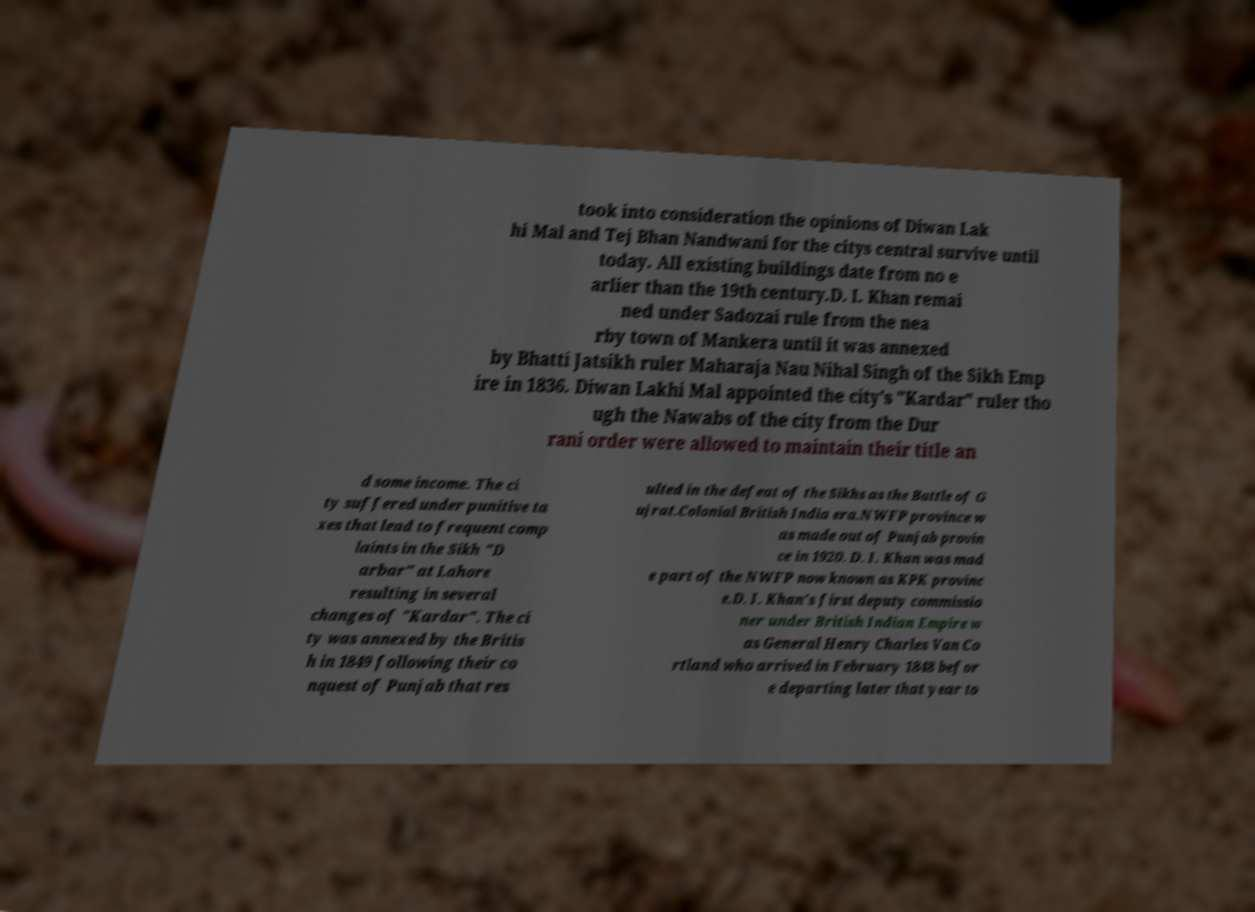Could you assist in decoding the text presented in this image and type it out clearly? took into consideration the opinions of Diwan Lak hi Mal and Tej Bhan Nandwani for the citys central survive until today. All existing buildings date from no e arlier than the 19th century.D. I. Khan remai ned under Sadozai rule from the nea rby town of Mankera until it was annexed by Bhatti Jatsikh ruler Maharaja Nau Nihal Singh of the Sikh Emp ire in 1836. Diwan Lakhi Mal appointed the city's "Kardar" ruler tho ugh the Nawabs of the city from the Dur rani order were allowed to maintain their title an d some income. The ci ty suffered under punitive ta xes that lead to frequent comp laints in the Sikh "D arbar" at Lahore resulting in several changes of "Kardar". The ci ty was annexed by the Britis h in 1849 following their co nquest of Punjab that res ulted in the defeat of the Sikhs as the Battle of G ujrat.Colonial British India era.NWFP province w as made out of Punjab provin ce in 1920. D. I. Khan was mad e part of the NWFP now known as KPK provinc e.D. I. Khan's first deputy commissio ner under British Indian Empire w as General Henry Charles Van Co rtland who arrived in February 1848 befor e departing later that year to 